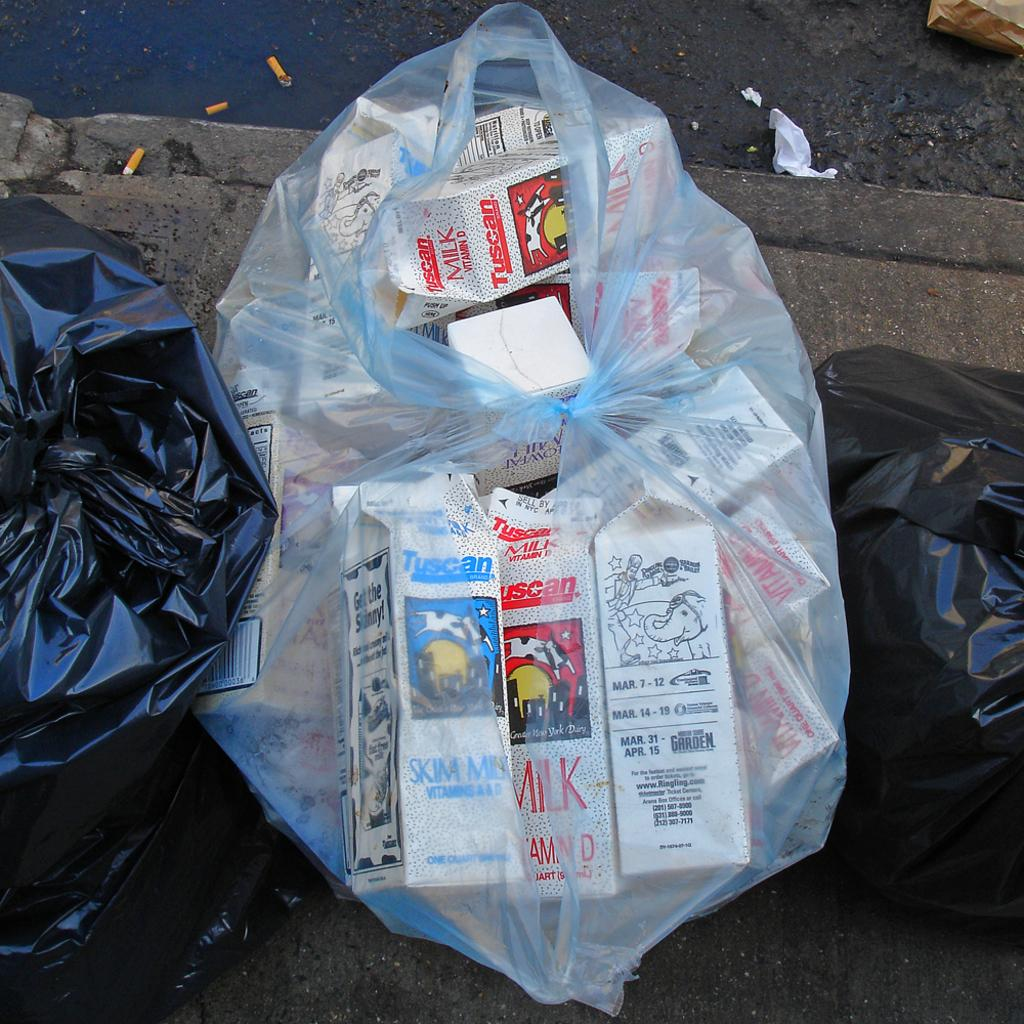What is contained in the containers that are visible in the image? There are milk cartons in the image. How are the milk cartons being transported or stored? The milk cartons are placed in polythene bags. What type of surface can be seen in the image? There is a road visible in the image. Can you see a fowl working as a carpenter in the image? No, there is no fowl or carpenter present in the image. 